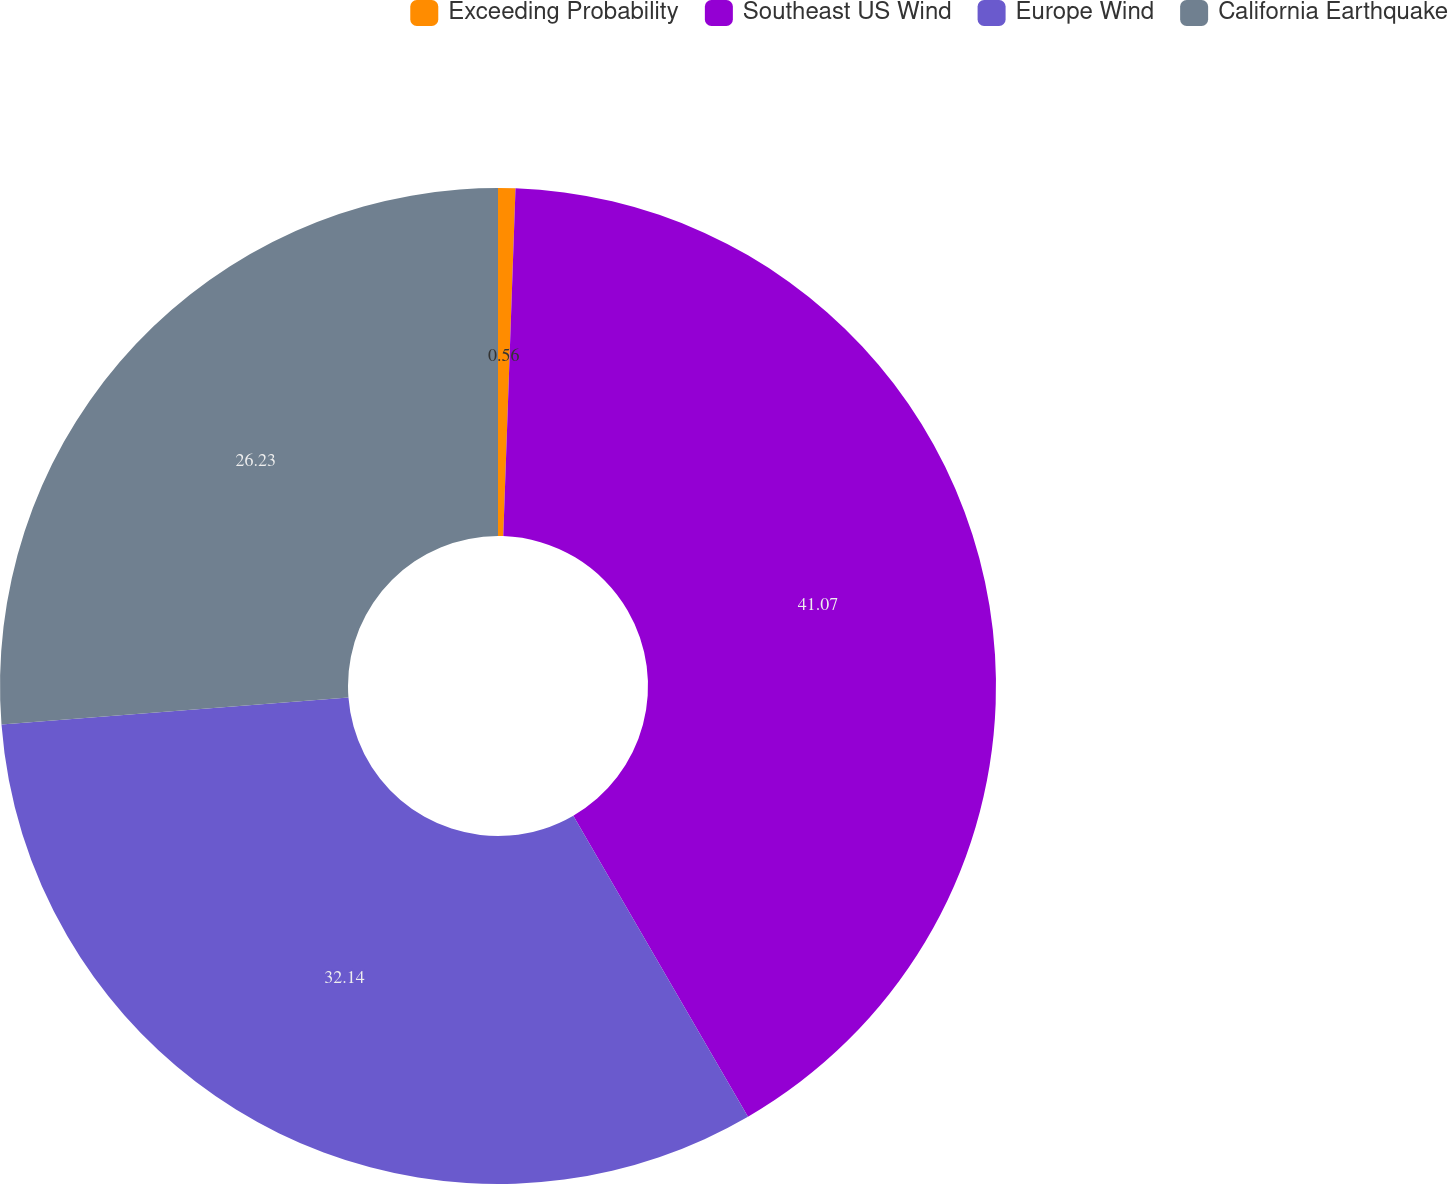Convert chart to OTSL. <chart><loc_0><loc_0><loc_500><loc_500><pie_chart><fcel>Exceeding Probability<fcel>Southeast US Wind<fcel>Europe Wind<fcel>California Earthquake<nl><fcel>0.56%<fcel>41.07%<fcel>32.14%<fcel>26.23%<nl></chart> 